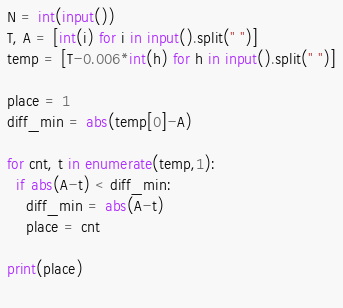Convert code to text. <code><loc_0><loc_0><loc_500><loc_500><_Python_>N = int(input())
T, A = [int(i) for i in input().split(" ")]
temp = [T-0.006*int(h) for h in input().split(" ")]

place = 1
diff_min = abs(temp[0]-A)

for cnt, t in enumerate(temp,1):
  if abs(A-t) < diff_min:
    diff_min = abs(A-t)
    place = cnt

print(place)
  </code> 